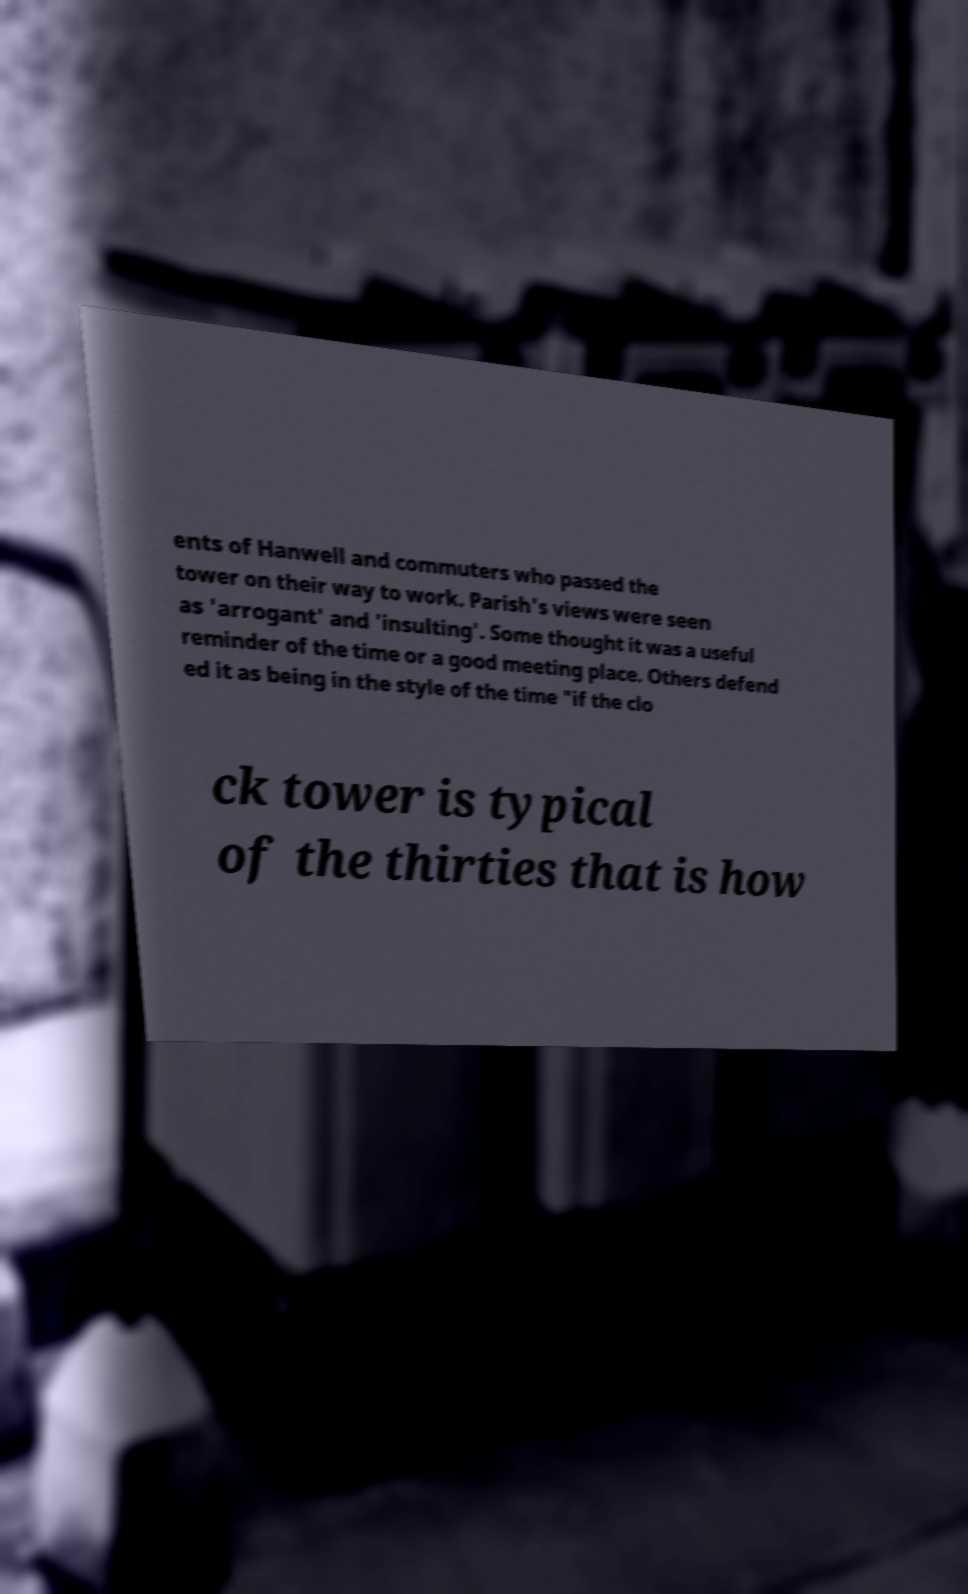For documentation purposes, I need the text within this image transcribed. Could you provide that? ents of Hanwell and commuters who passed the tower on their way to work. Parish's views were seen as 'arrogant' and 'insulting'. Some thought it was a useful reminder of the time or a good meeting place. Others defend ed it as being in the style of the time "if the clo ck tower is typical of the thirties that is how 